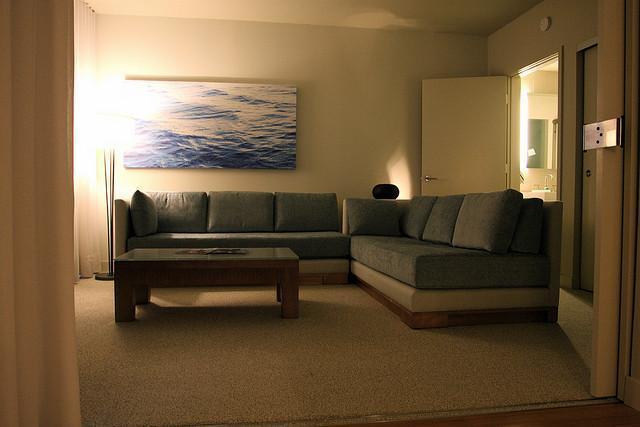How many pillows are on both couches?
Give a very brief answer. 8. How many buses are there going to max north?
Give a very brief answer. 0. 